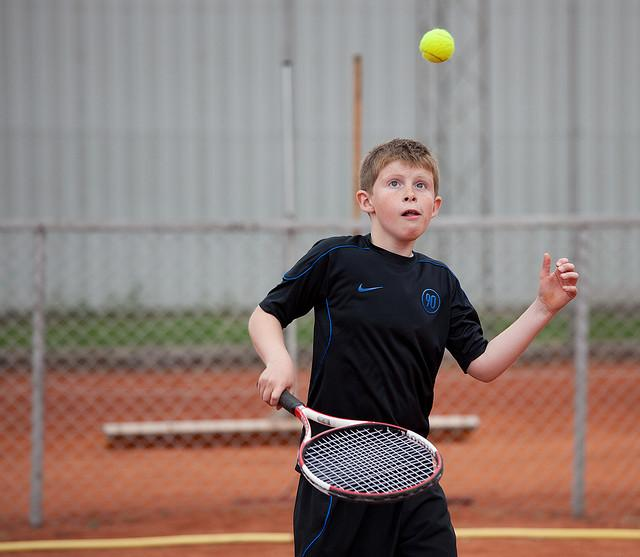What action will he take with the ball? hit 